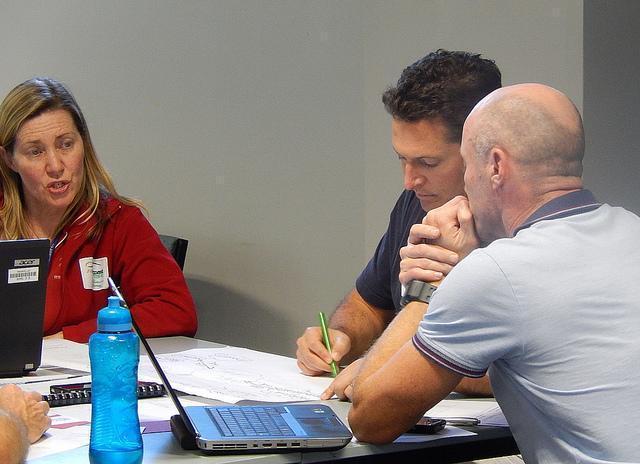The blue bottle is there to satisfy what need?
Make your selection and explain in format: 'Answer: answer
Rationale: rationale.'
Options: Elimination, thirst, medication, hunger. Answer: thirst.
Rationale: The bottle is for thirst. 